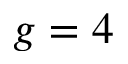Convert formula to latex. <formula><loc_0><loc_0><loc_500><loc_500>g = 4</formula> 